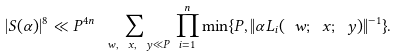<formula> <loc_0><loc_0><loc_500><loc_500>| S ( \alpha ) | ^ { 8 } \ll P ^ { 4 n } \sum _ { \ w , \ x , \ y \ll P } \, \prod _ { i = 1 } ^ { n } \min \{ P , \| \alpha L _ { i } ( \ w ; \ x ; \ y ) \| ^ { - 1 } \} .</formula> 